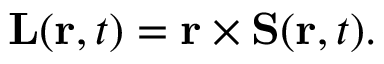<formula> <loc_0><loc_0><loc_500><loc_500>L ( r , t ) = r \times S ( r , t ) .</formula> 